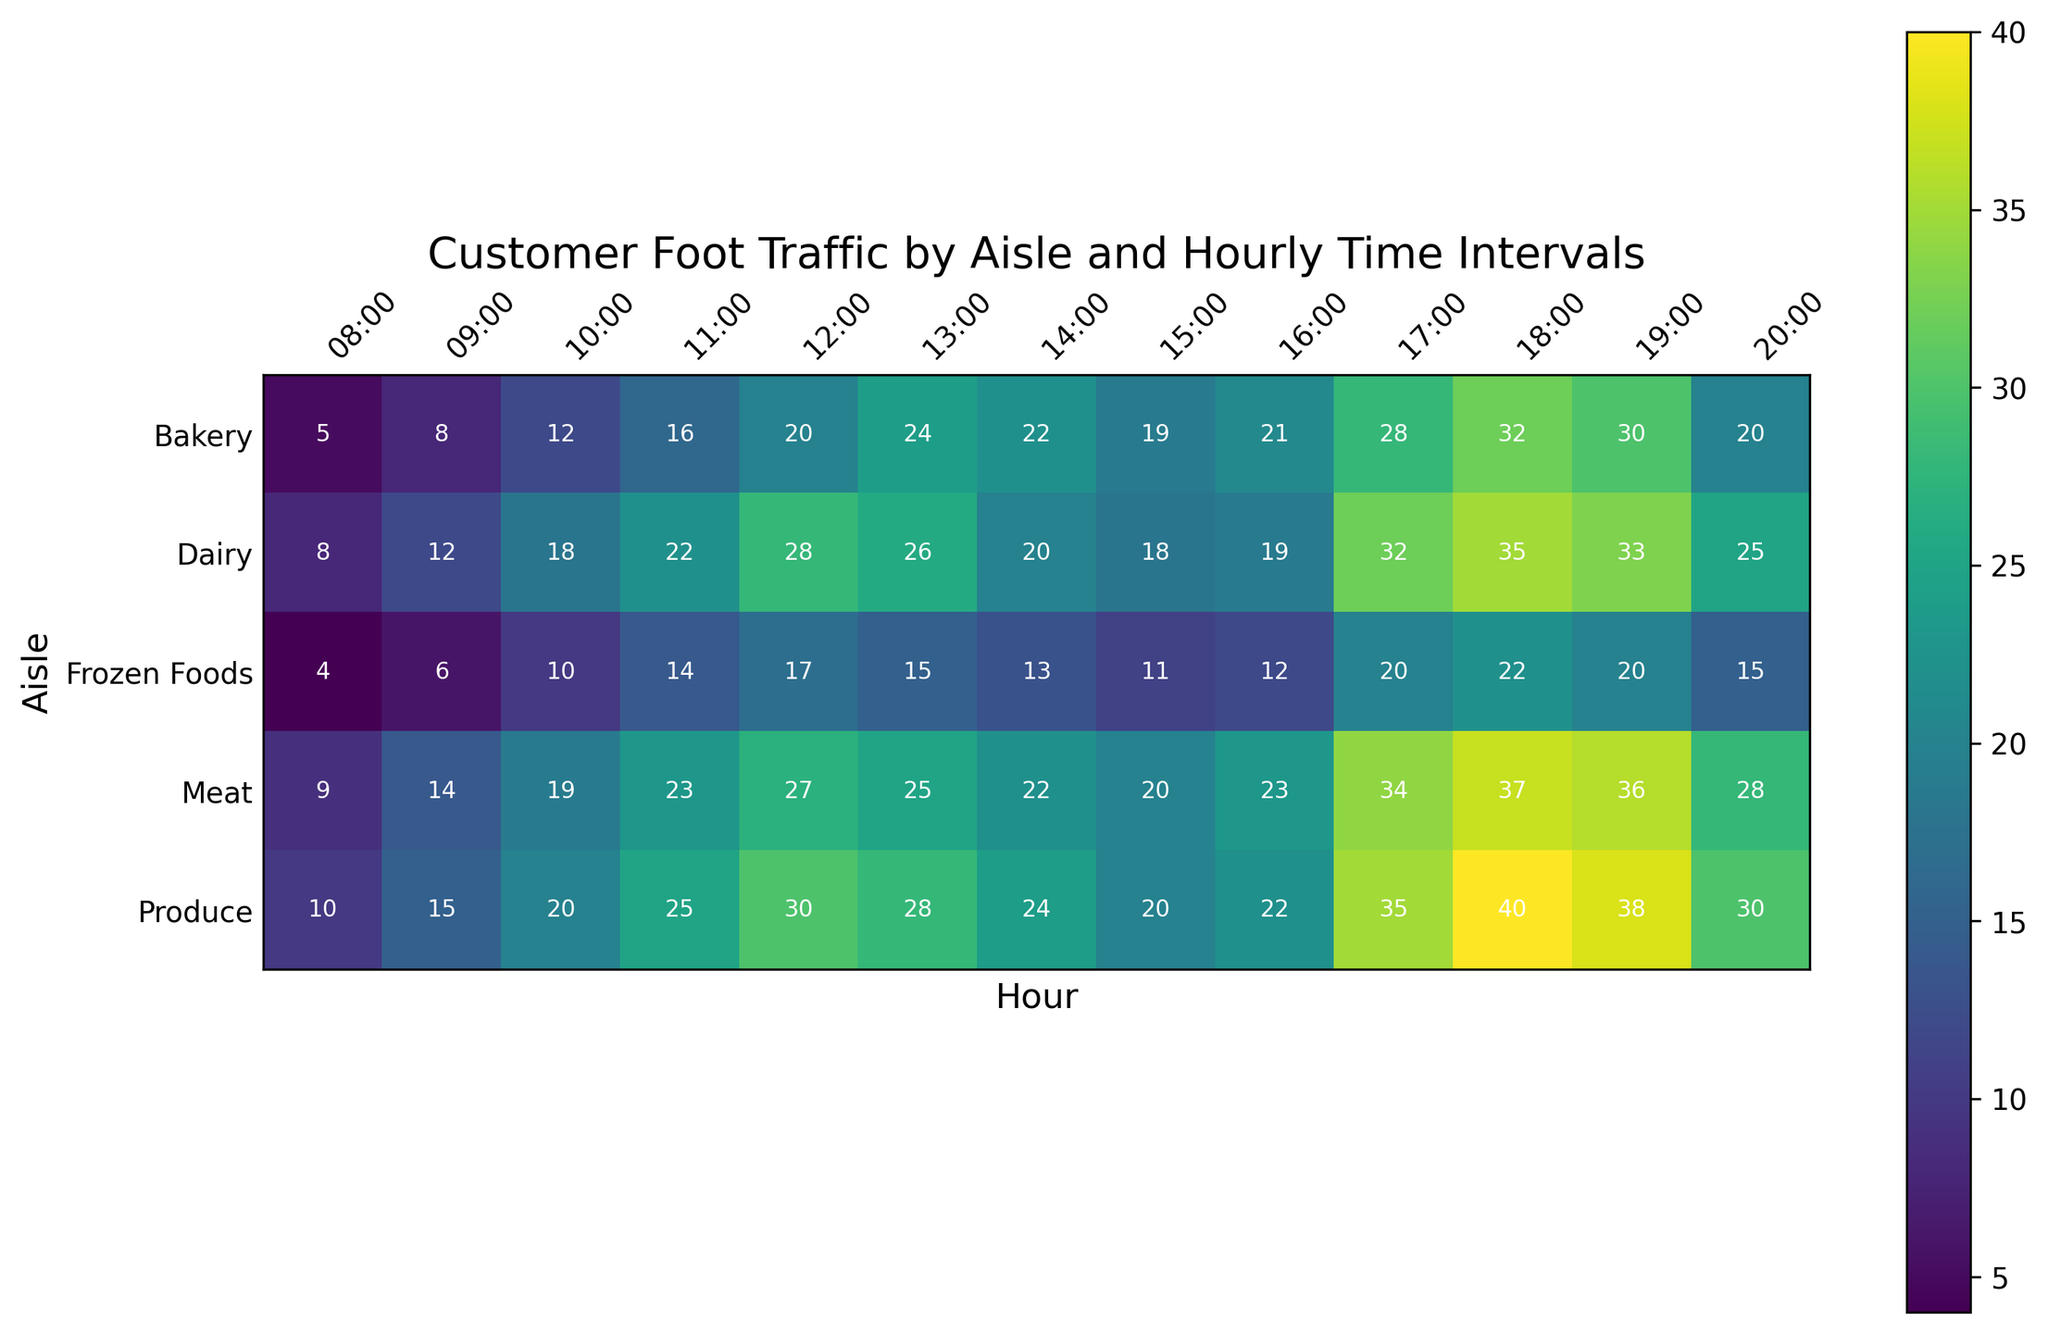Which aisle has the highest foot traffic at 18:00? To determine this, locate the 18:00 column and find the cell with the darkest shading, which corresponds to the highest numerical value. The value is 40 in the Produce aisle.
Answer: Produce What is the average foot traffic in the Produce aisle between 08:00 and 20:00? Sum the foot traffic values for the Produce aisle at all time intervals: 10 + 15 + 20 + 25 + 30 + 28 + 24 + 20 + 22 + 35 + 40 + 38 + 30. Then, divide by the number of intervals (13). The calculation is (10 + 15 + 20 + 25 + 30 + 28 + 24 + 20 + 22 + 35 + 40 + 38 + 30) / 13 = 337 / 13 = 25.92.
Answer: 25.92 Which time interval has the lowest overall foot traffic across all aisles? Sum the foot traffic values for each time interval across all aisles. The 08:00 interval yields the lowest value, with individual sums being 10 + 8 + 5 + 9 + 4 = 36.
Answer: 08:00 How does foot traffic at 17:00 compare between the Meat and Dairy aisles? Locate the 17:00 column and compare the values in the Meat and Dairy rows. The Meat aisle has 34 and the Dairy aisle has 32, so the Meat aisle has higher foot traffic.
Answer: Meat has higher foot traffic at 17:00 What is the difference in foot traffic between the Bakery and Frozen Foods aisles at 15:00? Find the values for the Bakery and Frozen Foods aisles at 15:00: Bakery has 19 and Frozen Foods has 11. The difference is 19 - 11 = 8.
Answer: 8 Which aisle shows the most consistent foot traffic throughout the day? Consistent foot traffic would be indicated by values that do not vary widely. Observing the foot traffic values across all hours for each aisle, the Dairy aisle shows the least variation (numbers range from 8 to 35).
Answer: Dairy During which hour do all aisles experience the highest combined foot traffic? Sum the foot traffic values for all aisles in each time interval and identify the maximum combined total. The hour 18:00 shows the highest combined foot traffic with values summing to 40 (Produce) + 35 (Dairy) + 32 (Bakery) + 37 (Meat) + 22 (Frozen Foods) = 166.
Answer: 18:00 